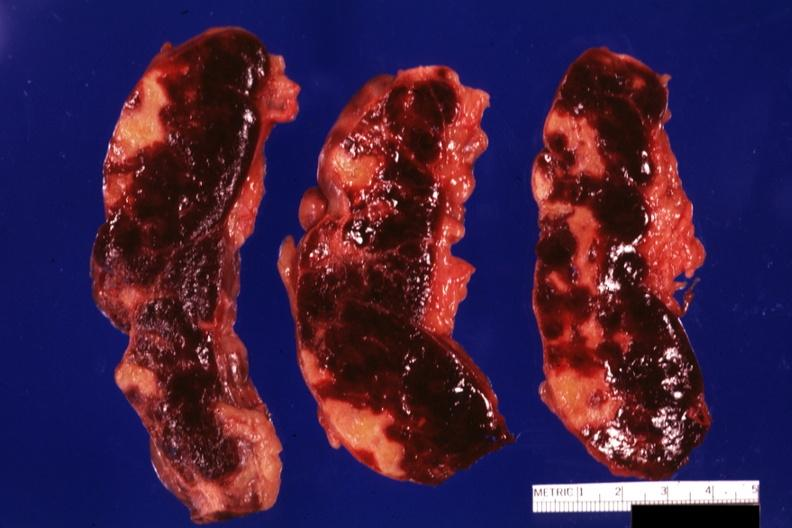what does this image show?
Answer the question using a single word or phrase. Three cut sections many lesions several days of age 